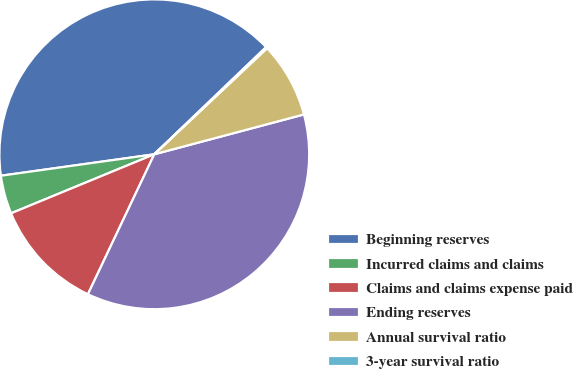Convert chart to OTSL. <chart><loc_0><loc_0><loc_500><loc_500><pie_chart><fcel>Beginning reserves<fcel>Incurred claims and claims<fcel>Claims and claims expense paid<fcel>Ending reserves<fcel>Annual survival ratio<fcel>3-year survival ratio<nl><fcel>40.05%<fcel>4.01%<fcel>11.73%<fcel>36.19%<fcel>7.87%<fcel>0.15%<nl></chart> 